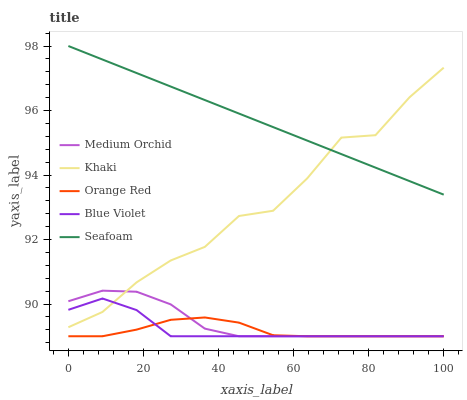Does Khaki have the minimum area under the curve?
Answer yes or no. No. Does Khaki have the maximum area under the curve?
Answer yes or no. No. Is Khaki the smoothest?
Answer yes or no. No. Is Seafoam the roughest?
Answer yes or no. No. Does Khaki have the lowest value?
Answer yes or no. No. Does Khaki have the highest value?
Answer yes or no. No. Is Orange Red less than Khaki?
Answer yes or no. Yes. Is Seafoam greater than Blue Violet?
Answer yes or no. Yes. Does Orange Red intersect Khaki?
Answer yes or no. No. 